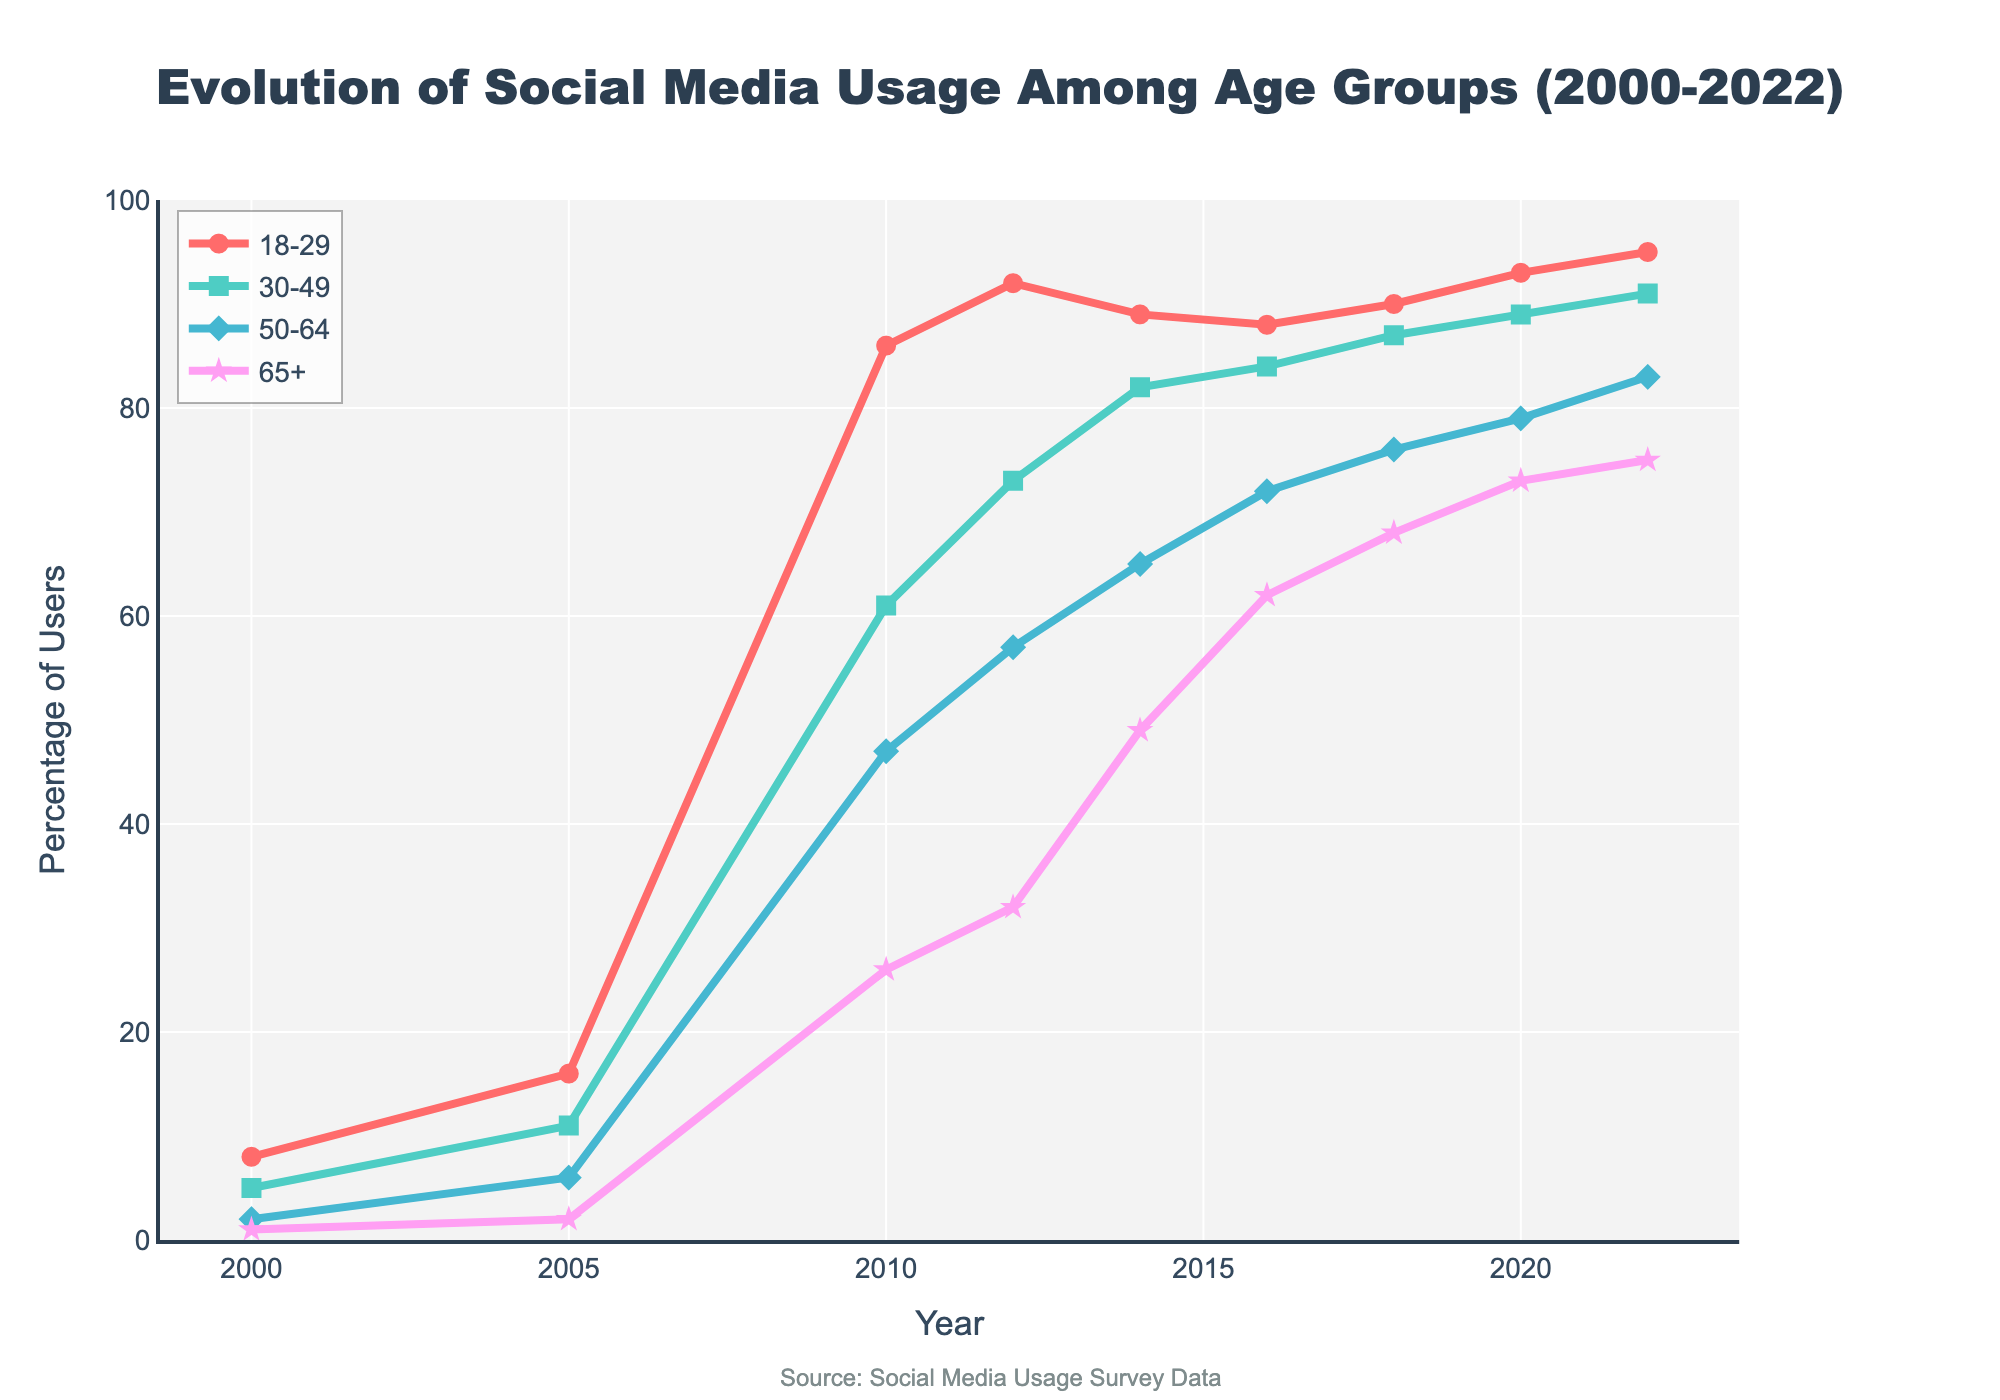What age group had the highest social media usage in 2005? Looking at the points for each age group in 2005, the 18-29 age group had the highest percentage of users.
Answer: 18-29 Between 2010 and 2022, which age group showed the smallest increase in social media usage? By comparing the percentage increases for each age group between 2010 and 2022: 
- 18-29: 95 - 86 = 9%
- 30-49: 91 - 61 = 30%
- 50-64: 83 - 47 = 36%
- 65+: 75 - 26 = 49%
The smallest increase is for the 18-29 age group.
Answer: 18-29 By how much did social media usage among the 65+ age group increase from 2000 to 2020? Subtract the 2000 value from the 2020 value for the 65+ group: 
2020: 73%
2000: 1%
Increase: 73 - 1 = 72%
Answer: 72% Which age group experienced the highest usage increase between 2000 and 2010? Calculating the increase for each group between 2000 and 2010:
- 18-29: 86 - 8 = 78%
- 30-49: 61 - 5 = 56%
- 50-64: 47 - 2 = 45%
- 65+: 26 - 1 = 25%
The highest increase is for the 18-29 age group.
Answer: 18-29 What is the difference in social media usage between the 30-49 and 50-64 age groups in 2022? Subtract the 50-64 percentage from the 30-49 percentage for 2022:
30-49: 91%
50-64: 83%
Difference: 91 - 83 = 8%
Answer: 8% By how many percentage points did the usage in the 50-64 age group change from 2014 to 2022? Subtract the 2014 value from the 2022 value for the 50-64 group:
2022: 83%
2014: 65%
Change: 83 - 65 = 18%
Answer: 18% What color represents the 18-29 age group in the plot? The 18-29 age group is represented by the color red in the plot.
Answer: red Between 2018 and 2022, which age group showed the largest increase in social media usage? Comparing the increases between 2018 and 2022 for each group:
- 18-29: 95 - 90 = 5%
- 30-49: 91 - 87 = 4%
- 50-64: 83 - 76 = 7%
- 65+: 75 - 68 = 7%
Both the 50-64 and 65+ age groups showed the largest increase of 7%.
Answer: 50-64 and 65+ Which year shows the largest jump in social media usage for the 18-29 age group? Compare the year-over-year differences for the 18-29 group and identify the largest jump:
- 2010: 86 - 2005: 16 = 70%
- 2012: 92 - 2010: 86 = 6%
- 2014: 89 - 2012: 92 = -3% (decrease)
- 2016: 88 - 2014: 89 = -1% (decrease)
- 2018: 90 - 2016: 88 = 2%
- 2020: 93 - 2018: 90 = 3%
- 2022: 95 - 2020: 93 = 2%
The largest jump is from 2005 to 2010.
Answer: 2010 Which year did the 30-49 age group cross the 50-64 age group in usage percentage? Identify the year where the 30-49 group's usage exceeded the 50-64 group's usage:
- 2010: 30-49 (61%) vs 50-64 (47%)
- 2012: 30-49 (73%) vs 50-64 (57%)
This happened in 2012.
Answer: 2012 